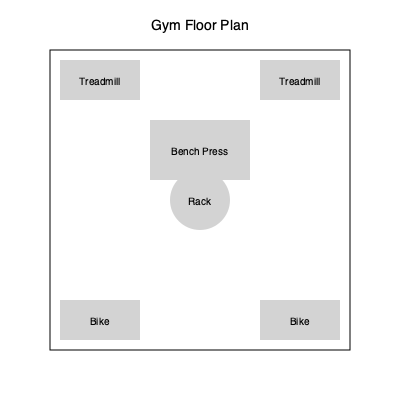Given the current gym floor plan, how many 90-degree rotations of the bench press equipment are needed to create a more efficient layout that allows for an additional treadmill to be placed along the top wall? To solve this problem, we need to follow these steps:

1. Analyze the current layout:
   - The bench press is horizontally oriented in the center of the gym.
   - There are two treadmills at the top, two bikes at the bottom, and a rack in the center.

2. Identify the goal:
   - We need to add one more treadmill along the top wall.
   - The bench press needs to be rotated to make space.

3. Determine the most efficient rotation:
   - A 90-degree rotation would position the bench press vertically.
   - This would create space along the top wall for an additional treadmill.

4. Calculate the number of rotations:
   - To go from horizontal to vertical, we need one 90-degree rotation.
   - The rotation should be clockwise or counterclockwise, depending on which side we want to place the new treadmill.

5. Verify the solution:
   - After one 90-degree rotation, the bench press will be vertical.
   - This new orientation leaves enough space for a third treadmill along the top wall.
   - No further rotations are necessary to achieve the goal.

Therefore, only one 90-degree rotation of the bench press is needed to create a more efficient layout that allows for an additional treadmill.
Answer: 1 